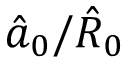<formula> <loc_0><loc_0><loc_500><loc_500>\hat { a } _ { 0 } / \hat { R } _ { 0 }</formula> 